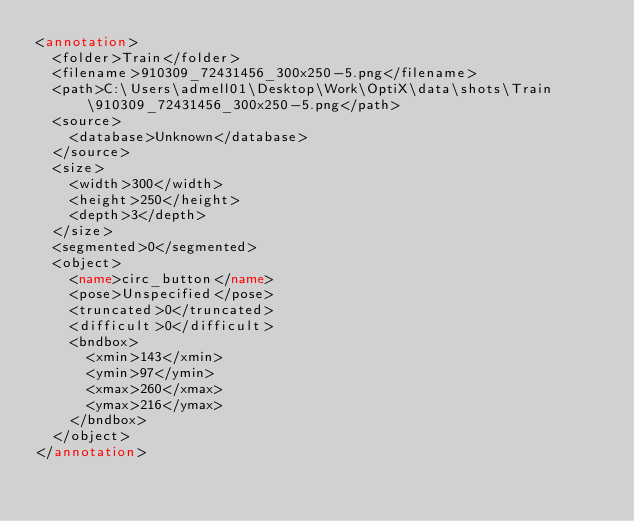<code> <loc_0><loc_0><loc_500><loc_500><_XML_><annotation>
	<folder>Train</folder>
	<filename>910309_72431456_300x250-5.png</filename>
	<path>C:\Users\admell01\Desktop\Work\OptiX\data\shots\Train\910309_72431456_300x250-5.png</path>
	<source>
		<database>Unknown</database>
	</source>
	<size>
		<width>300</width>
		<height>250</height>
		<depth>3</depth>
	</size>
	<segmented>0</segmented>
	<object>
		<name>circ_button</name>
		<pose>Unspecified</pose>
		<truncated>0</truncated>
		<difficult>0</difficult>
		<bndbox>
			<xmin>143</xmin>
			<ymin>97</ymin>
			<xmax>260</xmax>
			<ymax>216</ymax>
		</bndbox>
	</object>
</annotation>
</code> 